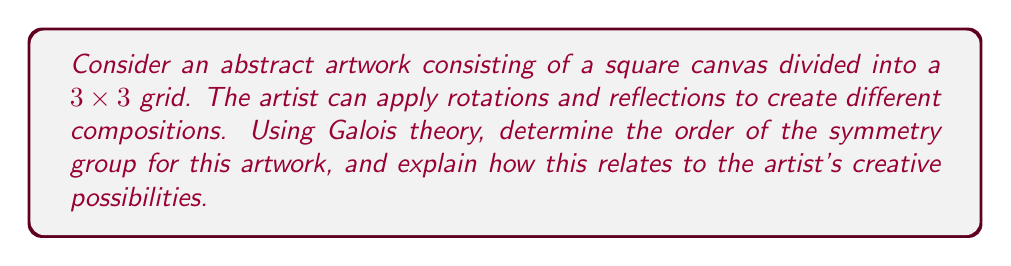Can you answer this question? 1. First, we identify the symmetry operations:
   - Rotations: 0°, 90°, 180°, 270°
   - Reflections: horizontal, vertical, and two diagonal axes

2. These symmetries form the dihedral group $D_4$, which is isomorphic to the symmetry group of a square.

3. To apply Galois theory, we consider the field extension $\mathbb{Q}(\zeta_8)/\mathbb{Q}$, where $\zeta_8$ is a primitive 8th root of unity.

4. The Galois group $Gal(\mathbb{Q}(\zeta_8)/\mathbb{Q})$ is isomorphic to $(\mathbb{Z}/8\mathbb{Z})^*$, which has order 4.

5. This Galois group is isomorphic to the cyclic group $C_4$, which is a subgroup of $D_4$.

6. The full symmetry group $D_4$ has order 8, which can be verified by counting the total number of symmetry operations (4 rotations and 4 reflections).

7. For the artist, this means there are 8 distinct ways to transform the artwork while preserving its overall structure.

8. Each element of the symmetry group corresponds to a unique arrangement of the 3x3 grid, providing a finite but rich set of compositional possibilities.

9. The artist can use these symmetries to explore balance, rhythm, and repetition in their abstract compositions, pushing the boundaries of visual expression within a structured mathematical framework.
Answer: 8 